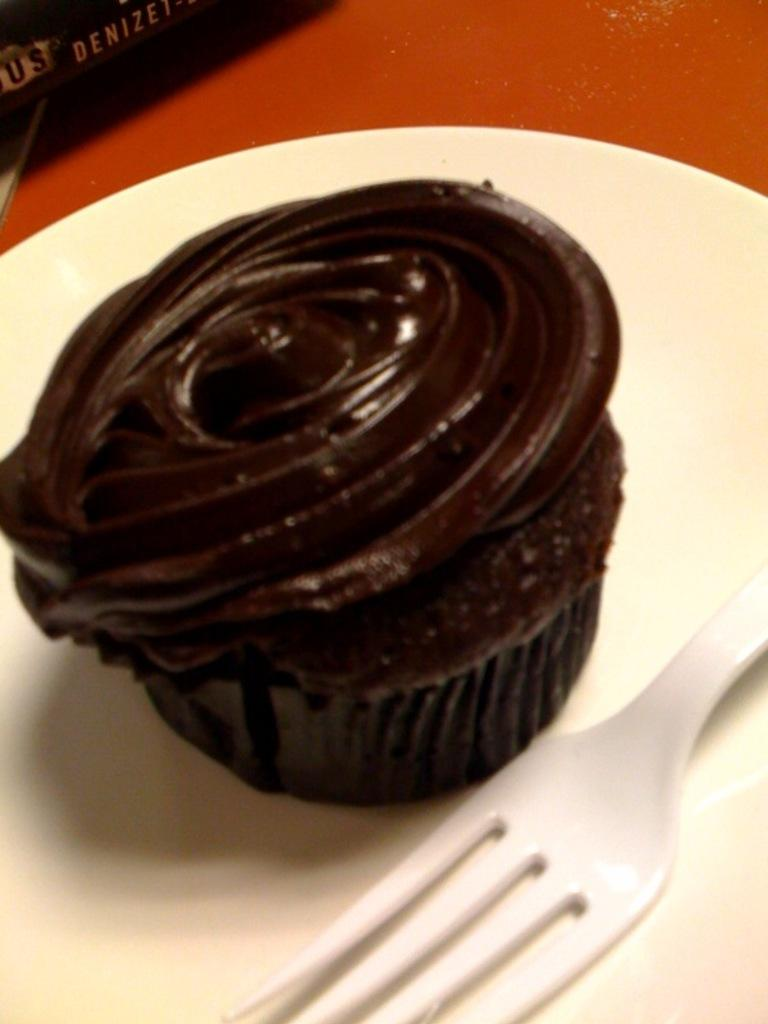What type of food item is visible in the image? There is a cupcake in the image. What utensil is present in the image? There is a fork in the image. Where are the cupcake and fork located? The cupcake and fork are placed on a plate. What type of cough medicine is visible in the image? There is no cough medicine present in the image; it features a cupcake and a fork on a plate. What type of system is being used to serve the cupcake in the image? There is no system visible in the image; it simply shows a cupcake, fork, and plate. 